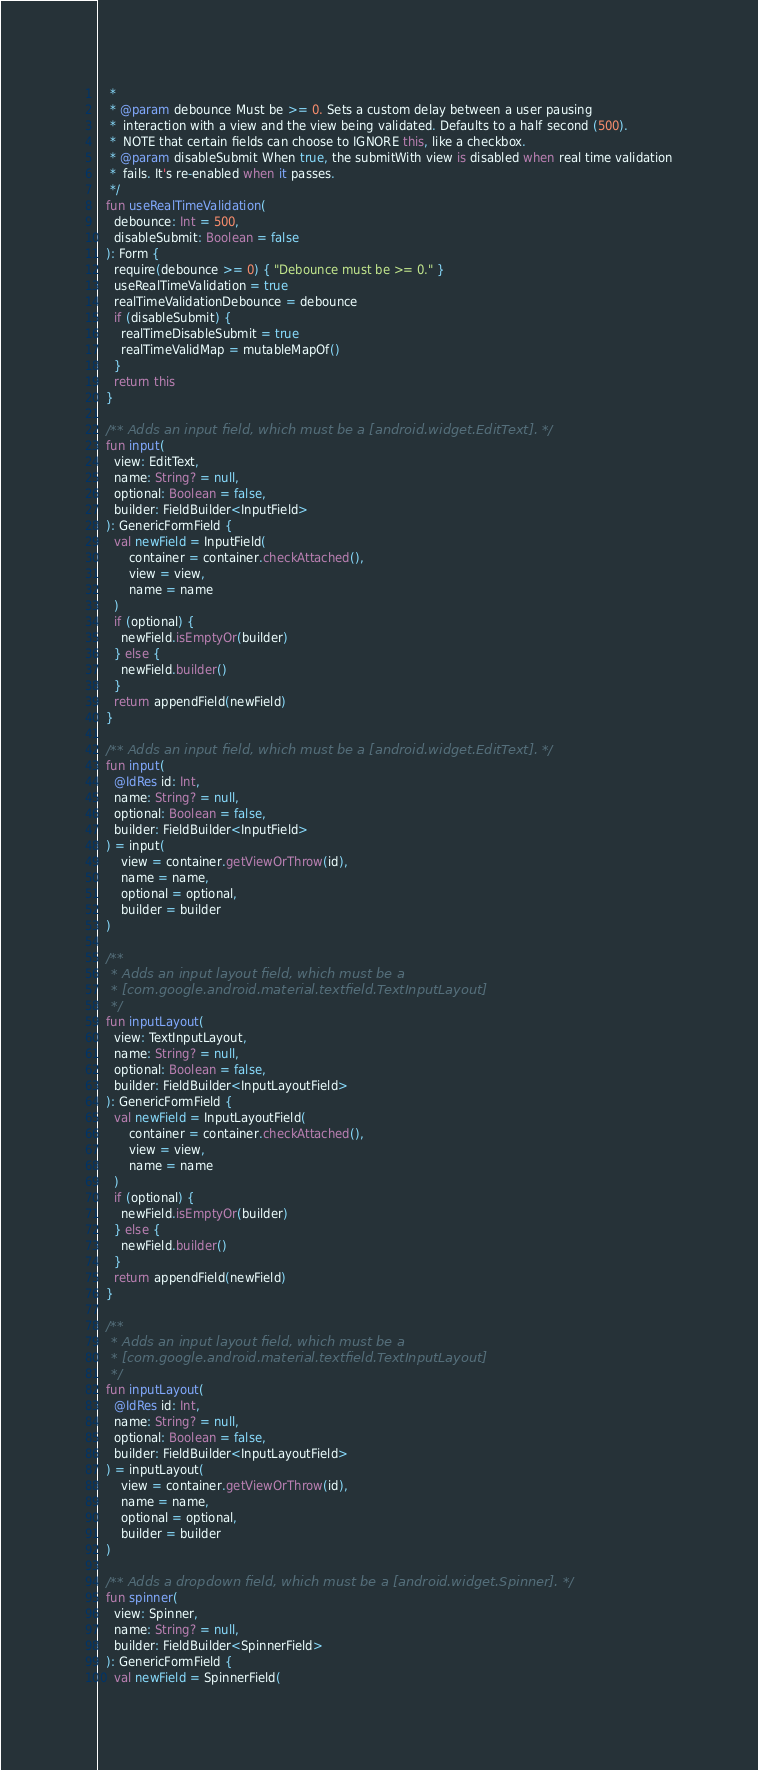Convert code to text. <code><loc_0><loc_0><loc_500><loc_500><_Kotlin_>   *
   * @param debounce Must be >= 0. Sets a custom delay between a user pausing
   *  interaction with a view and the view being validated. Defaults to a half second (500).
   *  NOTE that certain fields can choose to IGNORE this, like a checkbox.
   * @param disableSubmit When true, the submitWith view is disabled when real time validation
   *  fails. It's re-enabled when it passes.
   */
  fun useRealTimeValidation(
    debounce: Int = 500,
    disableSubmit: Boolean = false
  ): Form {
    require(debounce >= 0) { "Debounce must be >= 0." }
    useRealTimeValidation = true
    realTimeValidationDebounce = debounce
    if (disableSubmit) {
      realTimeDisableSubmit = true
      realTimeValidMap = mutableMapOf()
    }
    return this
  }

  /** Adds an input field, which must be a [android.widget.EditText]. */
  fun input(
    view: EditText,
    name: String? = null,
    optional: Boolean = false,
    builder: FieldBuilder<InputField>
  ): GenericFormField {
    val newField = InputField(
        container = container.checkAttached(),
        view = view,
        name = name
    )
    if (optional) {
      newField.isEmptyOr(builder)
    } else {
      newField.builder()
    }
    return appendField(newField)
  }

  /** Adds an input field, which must be a [android.widget.EditText]. */
  fun input(
    @IdRes id: Int,
    name: String? = null,
    optional: Boolean = false,
    builder: FieldBuilder<InputField>
  ) = input(
      view = container.getViewOrThrow(id),
      name = name,
      optional = optional,
      builder = builder
  )

  /**
   * Adds an input layout field, which must be a
   * [com.google.android.material.textfield.TextInputLayout]
   */
  fun inputLayout(
    view: TextInputLayout,
    name: String? = null,
    optional: Boolean = false,
    builder: FieldBuilder<InputLayoutField>
  ): GenericFormField {
    val newField = InputLayoutField(
        container = container.checkAttached(),
        view = view,
        name = name
    )
    if (optional) {
      newField.isEmptyOr(builder)
    } else {
      newField.builder()
    }
    return appendField(newField)
  }

  /**
   * Adds an input layout field, which must be a
   * [com.google.android.material.textfield.TextInputLayout]
   */
  fun inputLayout(
    @IdRes id: Int,
    name: String? = null,
    optional: Boolean = false,
    builder: FieldBuilder<InputLayoutField>
  ) = inputLayout(
      view = container.getViewOrThrow(id),
      name = name,
      optional = optional,
      builder = builder
  )

  /** Adds a dropdown field, which must be a [android.widget.Spinner]. */
  fun spinner(
    view: Spinner,
    name: String? = null,
    builder: FieldBuilder<SpinnerField>
  ): GenericFormField {
    val newField = SpinnerField(</code> 